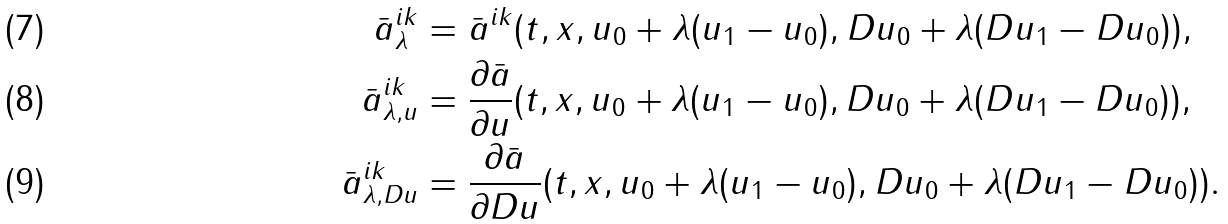Convert formula to latex. <formula><loc_0><loc_0><loc_500><loc_500>\bar { a } ^ { i k } _ { \lambda } & = \bar { a } ^ { i k } ( t , x , u _ { 0 } + \lambda ( u _ { 1 } - u _ { 0 } ) , D u _ { 0 } + \lambda ( D u _ { 1 } - D u _ { 0 } ) ) , \\ \bar { a } ^ { i k } _ { \lambda , u } & = \frac { \partial \bar { a } } { \partial u } ( t , x , u _ { 0 } + \lambda ( u _ { 1 } - u _ { 0 } ) , D u _ { 0 } + \lambda ( D u _ { 1 } - D u _ { 0 } ) ) , \\ \bar { a } ^ { i k } _ { \lambda , D u } & = \frac { \partial \bar { a } } { \partial D u } ( t , x , u _ { 0 } + \lambda ( u _ { 1 } - u _ { 0 } ) , D u _ { 0 } + \lambda ( D u _ { 1 } - D u _ { 0 } ) ) .</formula> 